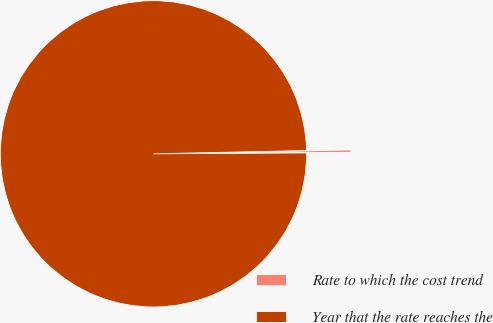Convert chart. <chart><loc_0><loc_0><loc_500><loc_500><pie_chart><fcel>Rate to which the cost trend<fcel>Year that the rate reaches the<nl><fcel>0.25%<fcel>99.75%<nl></chart> 